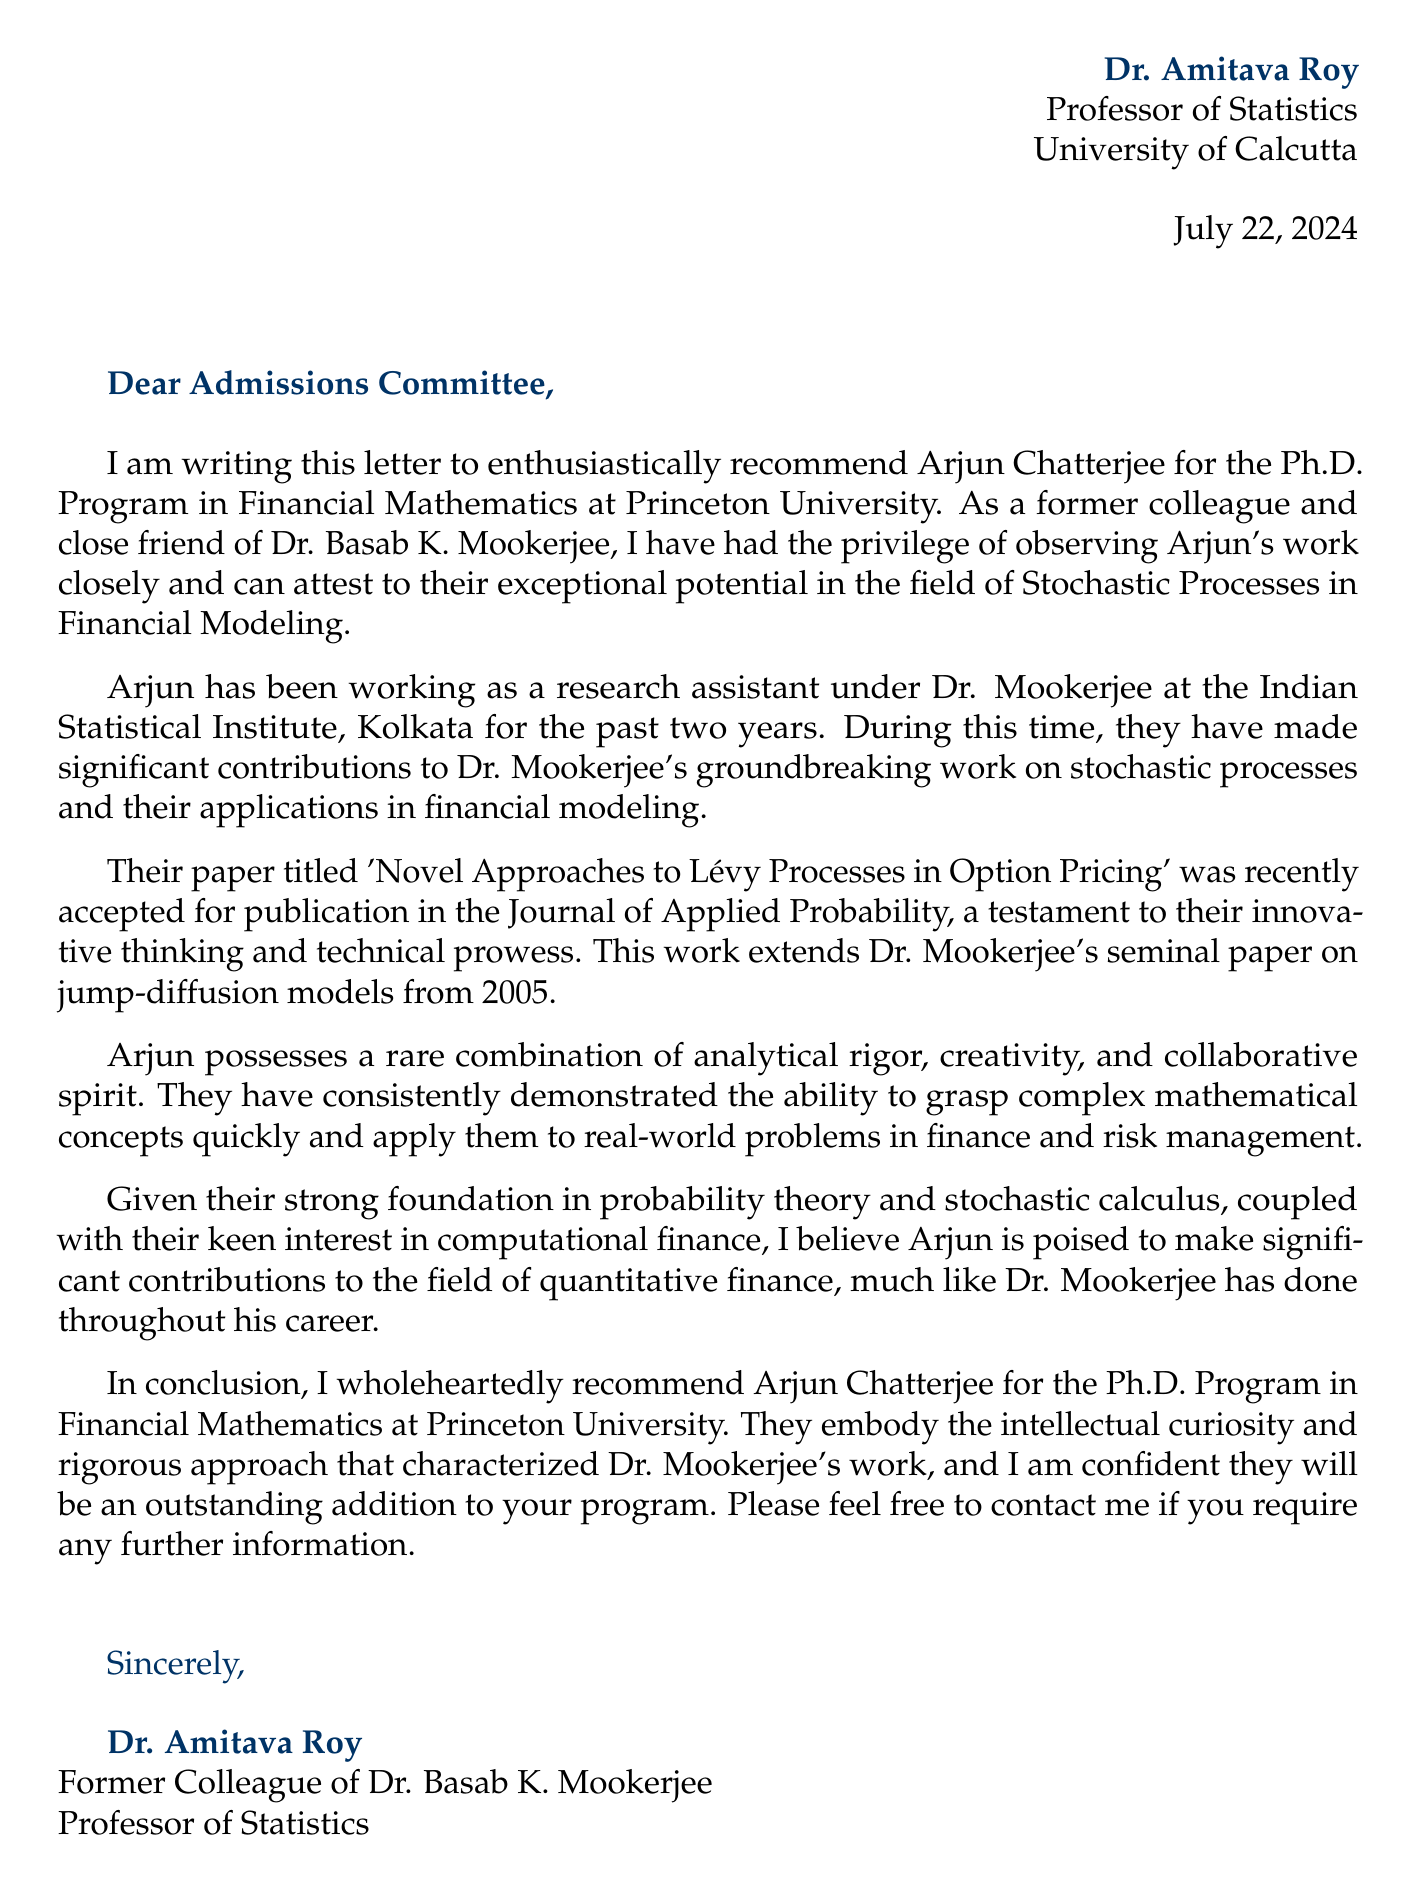What is the name of the researcher being recommended? The document specifically states the name of the researcher as Arjun Chatterjee.
Answer: Arjun Chatterjee Who is the letter addressed to? The salutation in the document indicates that it is addressed to the Admissions Committee.
Answer: Admissions Committee What position is Arjun Chatterjee applying for? The document mentions the Ph.D. Program in Financial Mathematics as the position Arjun is applying for.
Answer: Ph.D. Program in Financial Mathematics Which university is the recommendation for? The document clearly states that the recommendation is for Princeton University.
Answer: Princeton University What is the title of Arjun's paper? The document references the title of Arjun's paper as 'Novel Approaches to Lévy Processes in Option Pricing.'
Answer: Novel Approaches to Lévy Processes in Option Pricing What significant contribution did Arjun make in relation to Dr. Mookerjee's work? The document mentions that Arjun extended Dr. Mookerjee's seminal paper on jump-diffusion models from 2005.
Answer: Jump-diffusion models What is Dr. Mookerjee's full name? The document identifies Dr. Mookerjee's full name as Dr. Basab K. Mookerjee.
Answer: Dr. Basab K. Mookerjee Who is recommending Arjun Chatterjee? The letter identifies the person making the recommendation as Dr. Amitava Roy.
Answer: Dr. Amitava Roy What kind of qualities does Arjun possess according to the letter? The document describes Arjun as having analytical rigor, creativity, and a collaborative spirit.
Answer: Analytical rigor, creativity, and collaborative spirit 